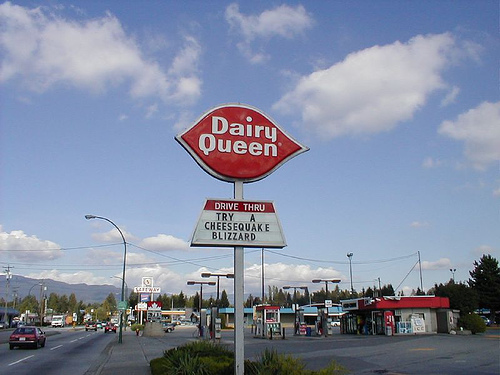<image>What kind of animal is shown on the car wash sign? It is ambiguous what kind of animal is shown on the car wash sign, it could be an elephant, beaver, octopus or none at all. What kind of animal is shown on the car wash sign? There is no animal shown on the car wash sign. 